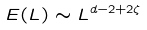<formula> <loc_0><loc_0><loc_500><loc_500>E ( L ) \sim L ^ { d - 2 + 2 \zeta }</formula> 